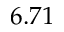Convert formula to latex. <formula><loc_0><loc_0><loc_500><loc_500>6 . 7 1</formula> 